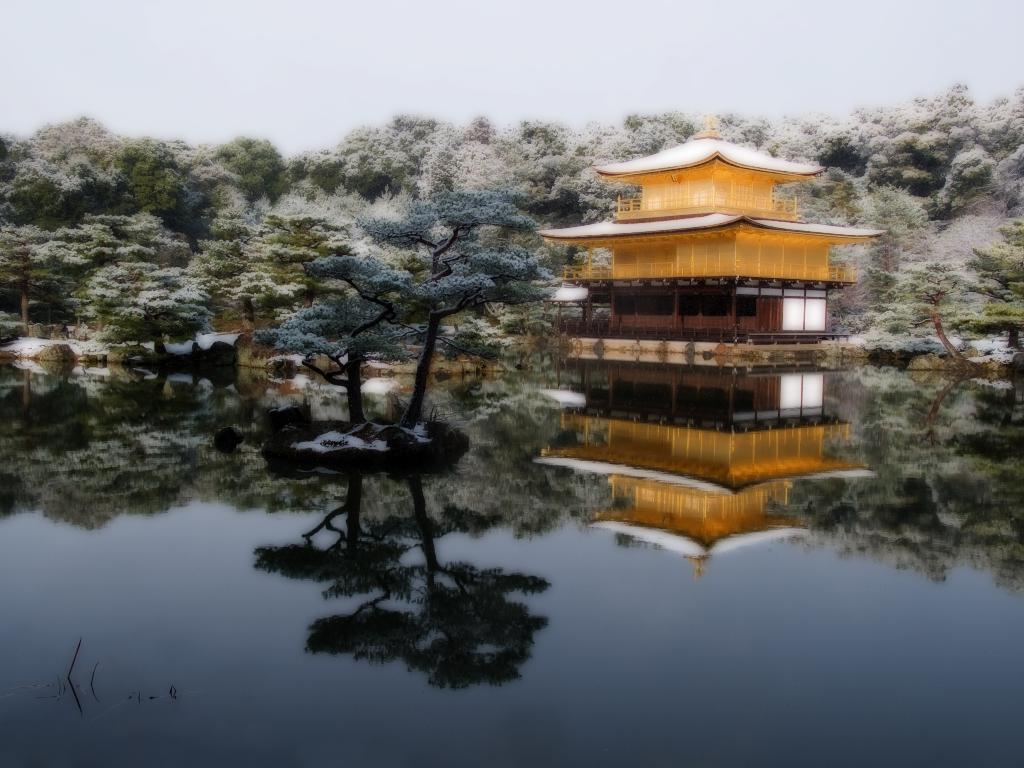What can be observed about the image's appearance? The image is edited. What is present at the bottom of the image? There is water at the bottom of the image. How many trees are in the water? There are two trees in the water. What can be seen in the background of the image? There is a house and many trees in the background of the image. What type of clover is growing on the house in the image? There is no clover present in the image, as the focus is on the trees and water. 